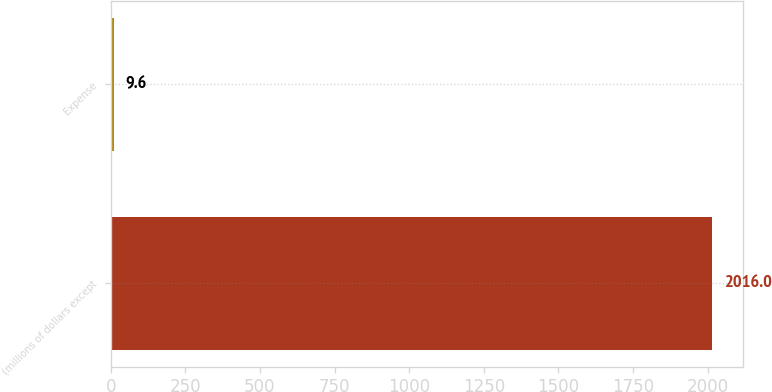Convert chart to OTSL. <chart><loc_0><loc_0><loc_500><loc_500><bar_chart><fcel>(millions of dollars except<fcel>Expense<nl><fcel>2016<fcel>9.6<nl></chart> 